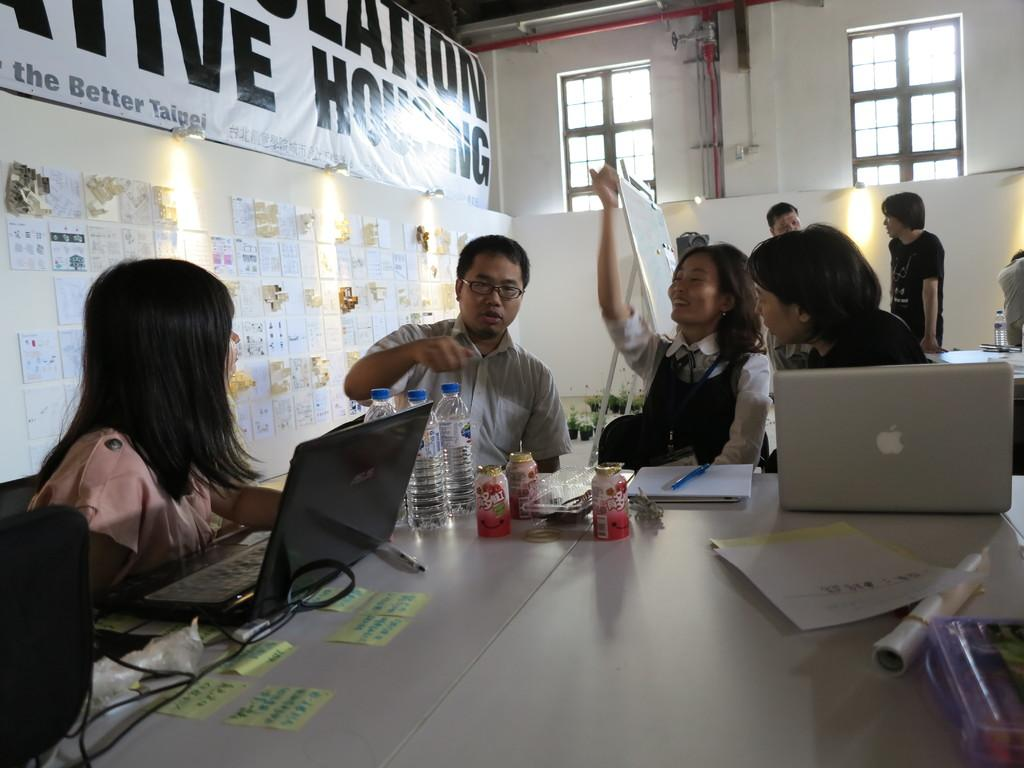What are the people in the image doing? The people in the image are sitting on chairs and working. What can be seen on the table in the image? There are many things on the table in the image. How many sheep can be seen grazing in the image? There are no sheep present in the image. What type of oatmeal is being served in the image? There is no oatmeal present in the image. 